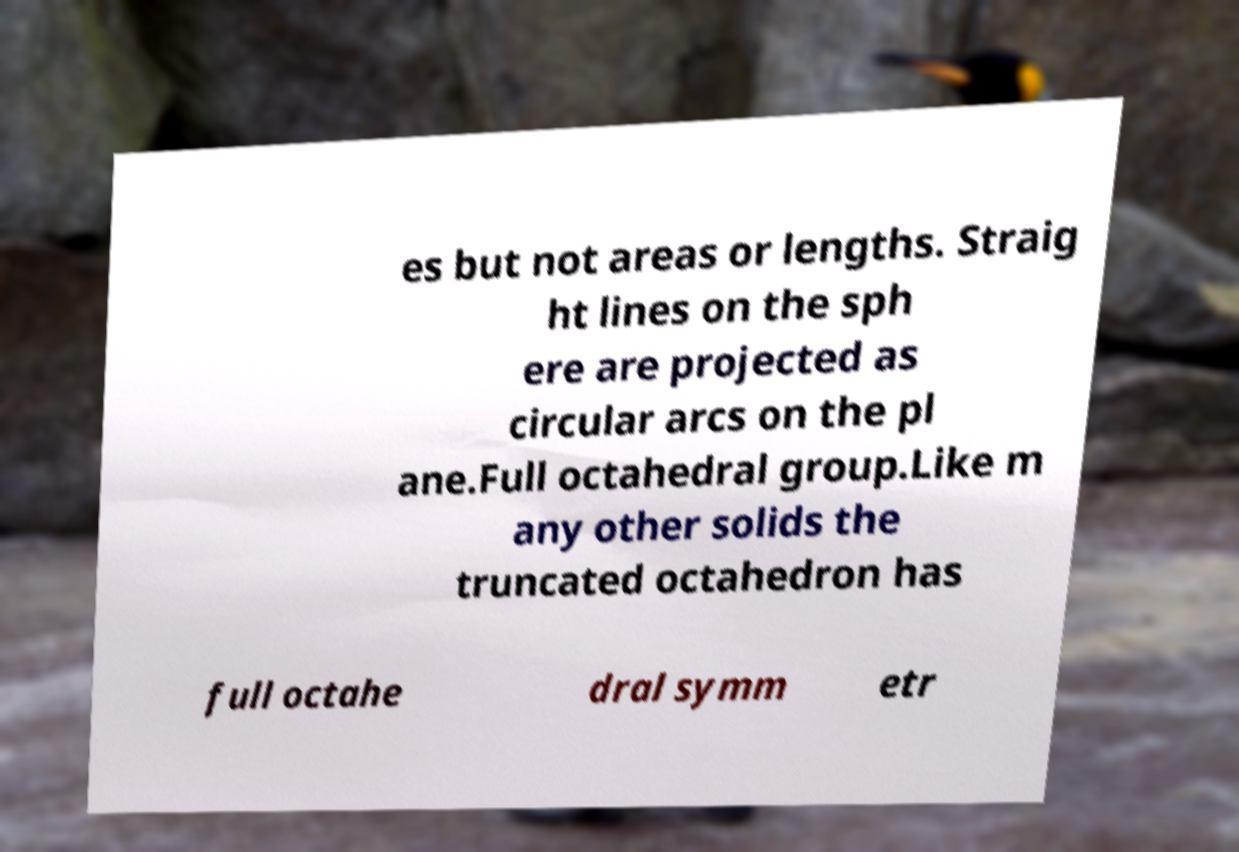I need the written content from this picture converted into text. Can you do that? es but not areas or lengths. Straig ht lines on the sph ere are projected as circular arcs on the pl ane.Full octahedral group.Like m any other solids the truncated octahedron has full octahe dral symm etr 